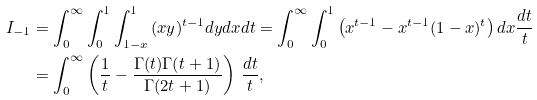<formula> <loc_0><loc_0><loc_500><loc_500>I _ { - 1 } & = { \int _ { 0 } ^ { \infty } { { \int _ { 0 } ^ { 1 } { { \int _ { 1 - x } ^ { 1 } { ( x y ) ^ { t - 1 } d y d x } } } } d t } } = { \int _ { 0 } ^ { \infty } { { \int _ { 0 } ^ { 1 } { \left ( { x ^ { t - 1 } - x ^ { t - 1 } ( 1 - x ) ^ { t } } \right ) \, } } d x { \frac { d t } { t } } } } \\ & = { \int _ { 0 } ^ { \infty } { \left ( { { \frac { 1 } { t } } - { \frac { \Gamma ( t ) \Gamma ( t + 1 ) } { \Gamma ( 2 t + 1 ) } } } \right ) \, { \frac { d t } { t } } } } ,</formula> 